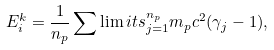<formula> <loc_0><loc_0><loc_500><loc_500>E ^ { k } _ { i } = \frac { 1 } { n _ { p } } \sum \lim i t s _ { j = 1 } ^ { n _ { p } } m _ { p } c ^ { 2 } ( \gamma _ { j } - 1 ) ,</formula> 